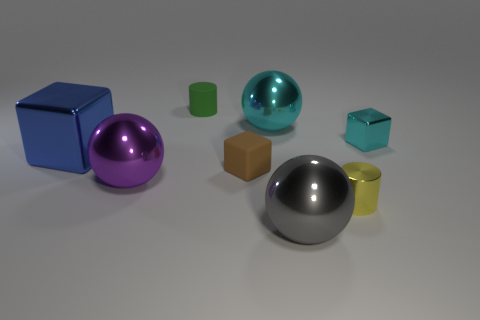Subtract all green cylinders. How many cylinders are left? 1 Subtract all cyan cubes. How many cubes are left? 2 Add 2 large blue things. How many objects exist? 10 Subtract 1 balls. How many balls are left? 2 Subtract all red spheres. Subtract all green cylinders. How many spheres are left? 3 Subtract all brown cylinders. How many green blocks are left? 0 Subtract 0 gray cylinders. How many objects are left? 8 Subtract all spheres. How many objects are left? 5 Subtract all large cyan shiny cylinders. Subtract all cyan metal cubes. How many objects are left? 7 Add 8 metallic cylinders. How many metallic cylinders are left? 9 